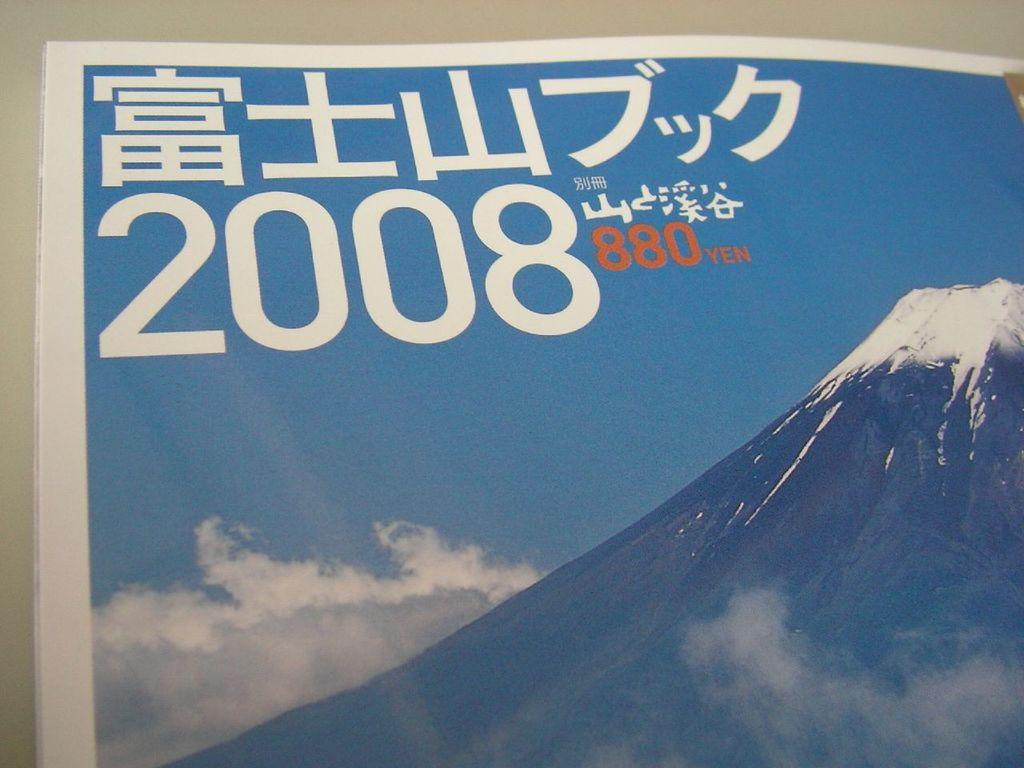<image>
Offer a succinct explanation of the picture presented. The foreign language and foreign alphabet calendar is dated 2008 and costs 880 yen. 